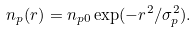Convert formula to latex. <formula><loc_0><loc_0><loc_500><loc_500>n _ { p } ( r ) = n _ { p 0 } \exp ( - r ^ { 2 } / \sigma _ { p } ^ { 2 } ) .</formula> 